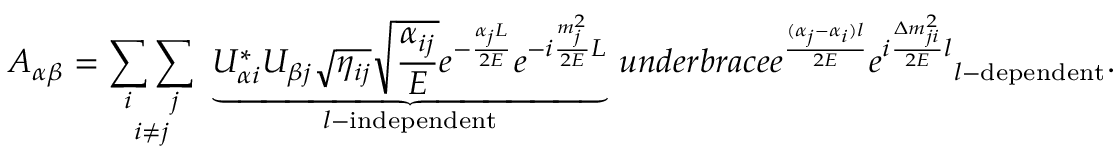<formula> <loc_0><loc_0><loc_500><loc_500>A _ { \alpha \beta } = \underset { i \neq j } { \sum _ { i } \sum _ { j } } \ \underbrace { U _ { \alpha i } ^ { * } U _ { \beta j } \sqrt { \eta _ { i j } } \sqrt { \frac { \alpha _ { i j } } { E } } e ^ { - \frac { \alpha _ { j } L } { 2 E } } e ^ { - i \frac { m _ { j } ^ { 2 } } { 2 E } L } } _ { l - i n d e p e n d e n t } \, u n d e r b r a c e { e ^ { \frac { ( \alpha _ { j } - \alpha _ { i } ) l } { 2 E } } e ^ { i \frac { \Delta m _ { j i } ^ { 2 } } { 2 E } l } } _ { l - d e p e n d e n t } .</formula> 